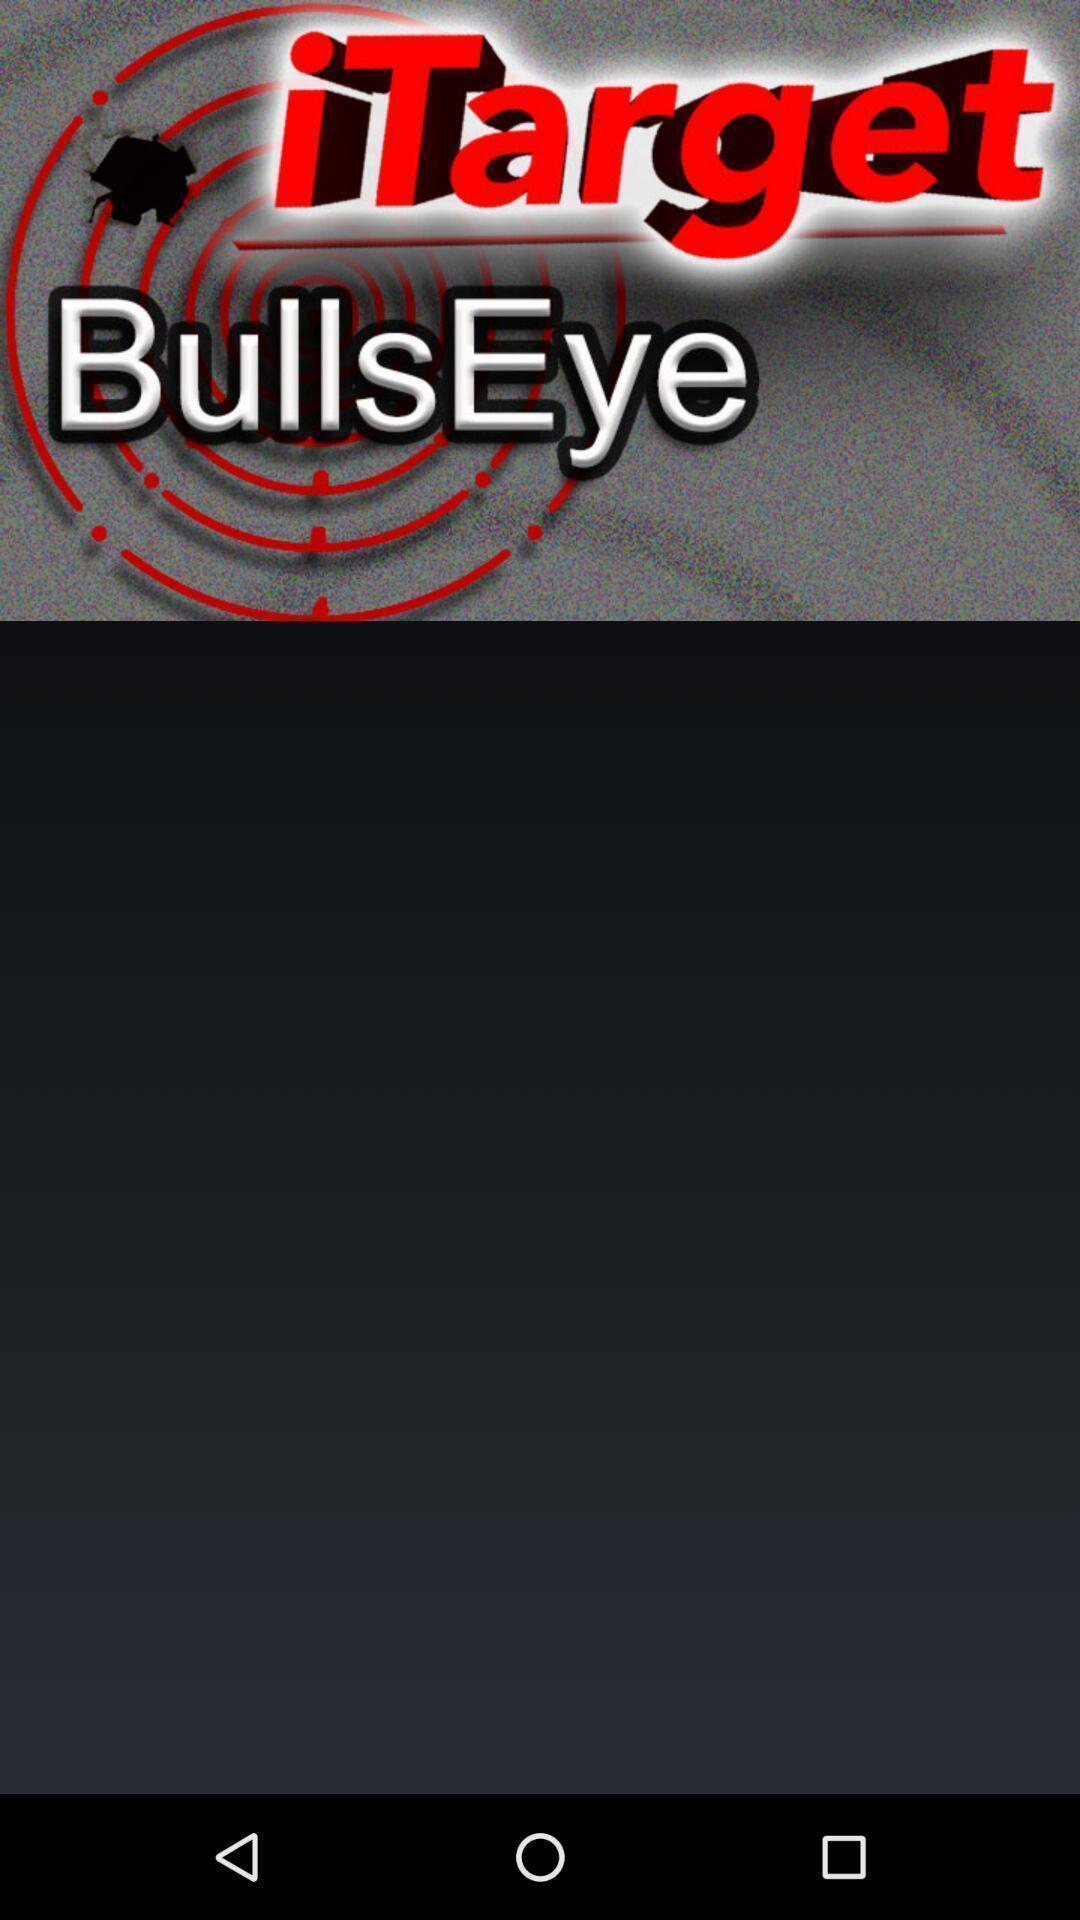Describe the key features of this screenshot. Screen showing page. 